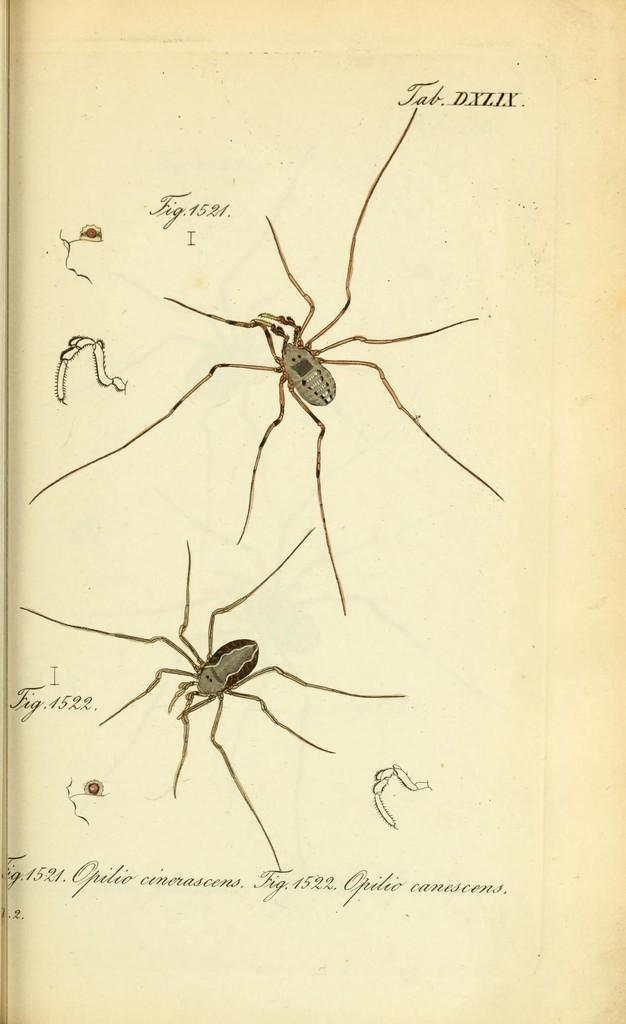What is present in the image that contains information? There is a paper in the image that contains information. What types of content can be found on the paper? The paper contains images and text. How do the sisters use the brake while driving in the image? There are no sisters or driving present in the image; it only contains a paper with images and text. 